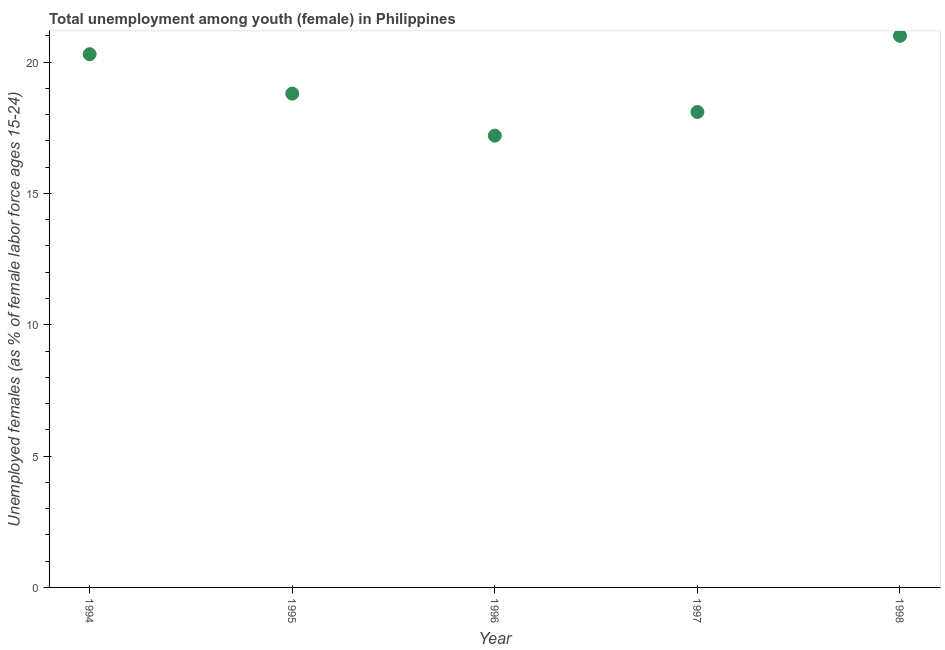What is the unemployed female youth population in 1998?
Keep it short and to the point. 21. Across all years, what is the minimum unemployed female youth population?
Your answer should be very brief. 17.2. In which year was the unemployed female youth population minimum?
Give a very brief answer. 1996. What is the sum of the unemployed female youth population?
Your answer should be compact. 95.4. What is the difference between the unemployed female youth population in 1995 and 1996?
Offer a very short reply. 1.6. What is the average unemployed female youth population per year?
Your response must be concise. 19.08. What is the median unemployed female youth population?
Ensure brevity in your answer.  18.8. In how many years, is the unemployed female youth population greater than 6 %?
Provide a succinct answer. 5. What is the ratio of the unemployed female youth population in 1996 to that in 1997?
Make the answer very short. 0.95. Is the unemployed female youth population in 1994 less than that in 1996?
Your answer should be compact. No. What is the difference between the highest and the second highest unemployed female youth population?
Offer a terse response. 0.7. What is the difference between the highest and the lowest unemployed female youth population?
Offer a terse response. 3.8. In how many years, is the unemployed female youth population greater than the average unemployed female youth population taken over all years?
Keep it short and to the point. 2. How many years are there in the graph?
Your answer should be compact. 5. What is the difference between two consecutive major ticks on the Y-axis?
Your answer should be compact. 5. Does the graph contain any zero values?
Provide a succinct answer. No. Does the graph contain grids?
Give a very brief answer. No. What is the title of the graph?
Make the answer very short. Total unemployment among youth (female) in Philippines. What is the label or title of the Y-axis?
Give a very brief answer. Unemployed females (as % of female labor force ages 15-24). What is the Unemployed females (as % of female labor force ages 15-24) in 1994?
Ensure brevity in your answer.  20.3. What is the Unemployed females (as % of female labor force ages 15-24) in 1995?
Make the answer very short. 18.8. What is the Unemployed females (as % of female labor force ages 15-24) in 1996?
Keep it short and to the point. 17.2. What is the Unemployed females (as % of female labor force ages 15-24) in 1997?
Keep it short and to the point. 18.1. What is the Unemployed females (as % of female labor force ages 15-24) in 1998?
Offer a terse response. 21. What is the difference between the Unemployed females (as % of female labor force ages 15-24) in 1994 and 1995?
Give a very brief answer. 1.5. What is the difference between the Unemployed females (as % of female labor force ages 15-24) in 1994 and 1996?
Your answer should be compact. 3.1. What is the difference between the Unemployed females (as % of female labor force ages 15-24) in 1994 and 1997?
Provide a short and direct response. 2.2. What is the difference between the Unemployed females (as % of female labor force ages 15-24) in 1995 and 1997?
Give a very brief answer. 0.7. What is the difference between the Unemployed females (as % of female labor force ages 15-24) in 1996 and 1997?
Offer a terse response. -0.9. What is the difference between the Unemployed females (as % of female labor force ages 15-24) in 1997 and 1998?
Offer a very short reply. -2.9. What is the ratio of the Unemployed females (as % of female labor force ages 15-24) in 1994 to that in 1996?
Offer a terse response. 1.18. What is the ratio of the Unemployed females (as % of female labor force ages 15-24) in 1994 to that in 1997?
Offer a very short reply. 1.12. What is the ratio of the Unemployed females (as % of female labor force ages 15-24) in 1995 to that in 1996?
Give a very brief answer. 1.09. What is the ratio of the Unemployed females (as % of female labor force ages 15-24) in 1995 to that in 1997?
Your answer should be compact. 1.04. What is the ratio of the Unemployed females (as % of female labor force ages 15-24) in 1995 to that in 1998?
Your answer should be compact. 0.9. What is the ratio of the Unemployed females (as % of female labor force ages 15-24) in 1996 to that in 1998?
Your answer should be very brief. 0.82. What is the ratio of the Unemployed females (as % of female labor force ages 15-24) in 1997 to that in 1998?
Make the answer very short. 0.86. 